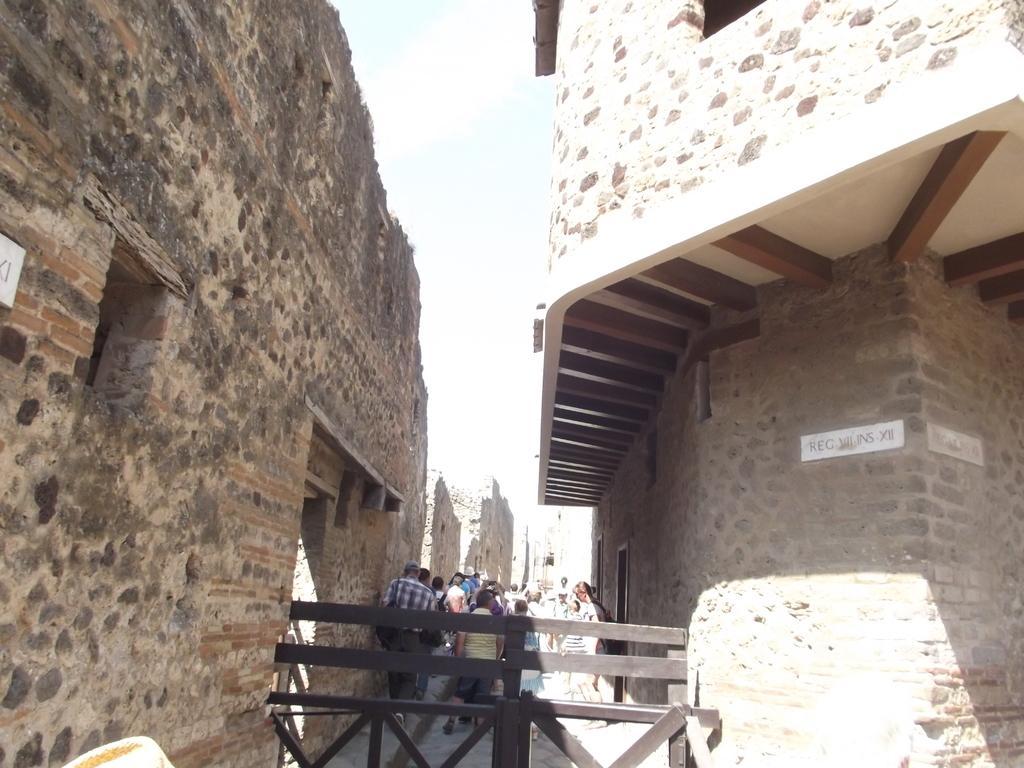How would you summarize this image in a sentence or two? In this image few persons are walking on the path behind the fence. Background there are few buildings. A person is wearing a shirt is having a cap. 